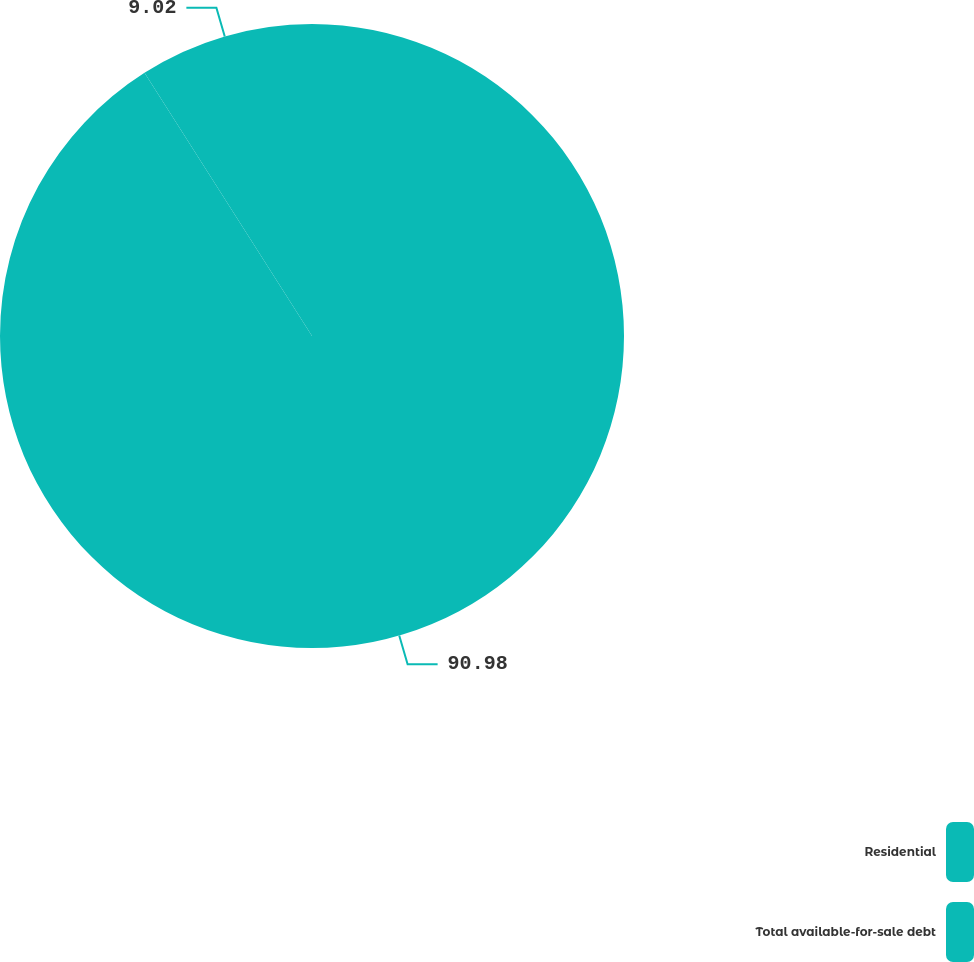Convert chart. <chart><loc_0><loc_0><loc_500><loc_500><pie_chart><fcel>Residential<fcel>Total available-for-sale debt<nl><fcel>90.98%<fcel>9.02%<nl></chart> 